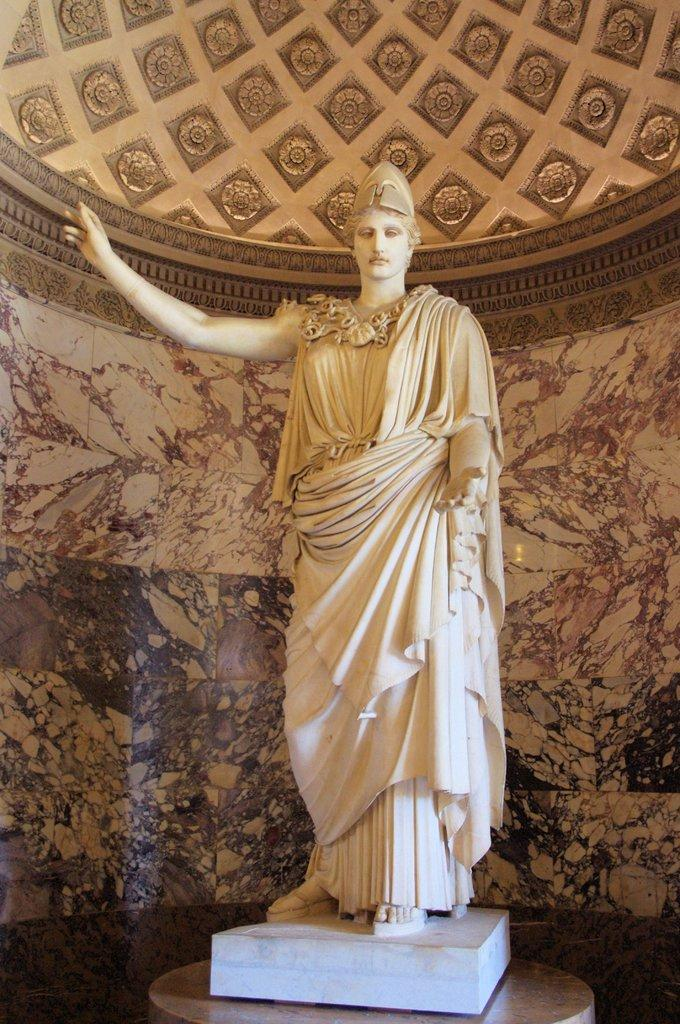What is the main subject of the image? There is a sculpture of a person standing in the image. What is located behind the sculpture? There is a wall behind the sculpture. What part of the room can be seen at the top of the image? There is a ceiling visible at the top of the image. Can you see a dog playing on the seashore in the image? No, there is no dog or seashore present in the image; it features a sculpture of a person standing in front of a wall with a ceiling visible at the top. 